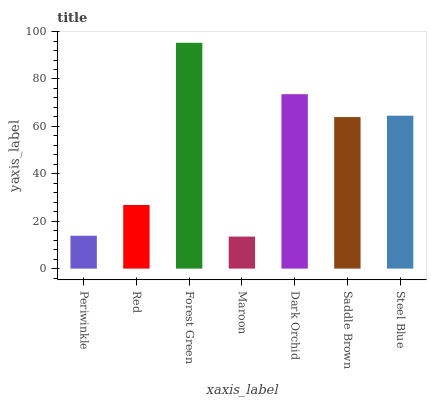Is Maroon the minimum?
Answer yes or no. Yes. Is Forest Green the maximum?
Answer yes or no. Yes. Is Red the minimum?
Answer yes or no. No. Is Red the maximum?
Answer yes or no. No. Is Red greater than Periwinkle?
Answer yes or no. Yes. Is Periwinkle less than Red?
Answer yes or no. Yes. Is Periwinkle greater than Red?
Answer yes or no. No. Is Red less than Periwinkle?
Answer yes or no. No. Is Saddle Brown the high median?
Answer yes or no. Yes. Is Saddle Brown the low median?
Answer yes or no. Yes. Is Periwinkle the high median?
Answer yes or no. No. Is Steel Blue the low median?
Answer yes or no. No. 